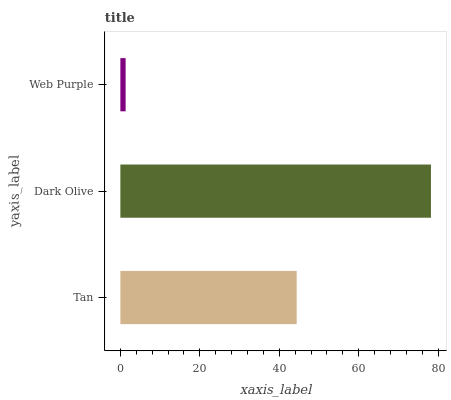Is Web Purple the minimum?
Answer yes or no. Yes. Is Dark Olive the maximum?
Answer yes or no. Yes. Is Dark Olive the minimum?
Answer yes or no. No. Is Web Purple the maximum?
Answer yes or no. No. Is Dark Olive greater than Web Purple?
Answer yes or no. Yes. Is Web Purple less than Dark Olive?
Answer yes or no. Yes. Is Web Purple greater than Dark Olive?
Answer yes or no. No. Is Dark Olive less than Web Purple?
Answer yes or no. No. Is Tan the high median?
Answer yes or no. Yes. Is Tan the low median?
Answer yes or no. Yes. Is Web Purple the high median?
Answer yes or no. No. Is Dark Olive the low median?
Answer yes or no. No. 